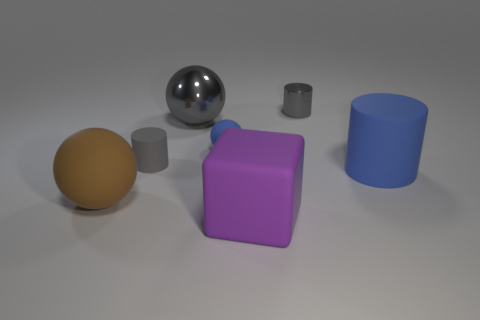Subtract 1 spheres. How many spheres are left? 2 Add 2 big brown cylinders. How many objects exist? 9 Subtract all balls. How many objects are left? 4 Subtract all big green shiny blocks. Subtract all big blue matte cylinders. How many objects are left? 6 Add 7 purple things. How many purple things are left? 8 Add 5 blue balls. How many blue balls exist? 6 Subtract 0 gray cubes. How many objects are left? 7 